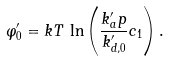Convert formula to latex. <formula><loc_0><loc_0><loc_500><loc_500>\varphi ^ { \prime } _ { 0 } = k T \, \ln \left ( \frac { k ^ { \prime } _ { a } p } { k ^ { \prime } _ { d , 0 } } c _ { 1 } \right ) .</formula> 